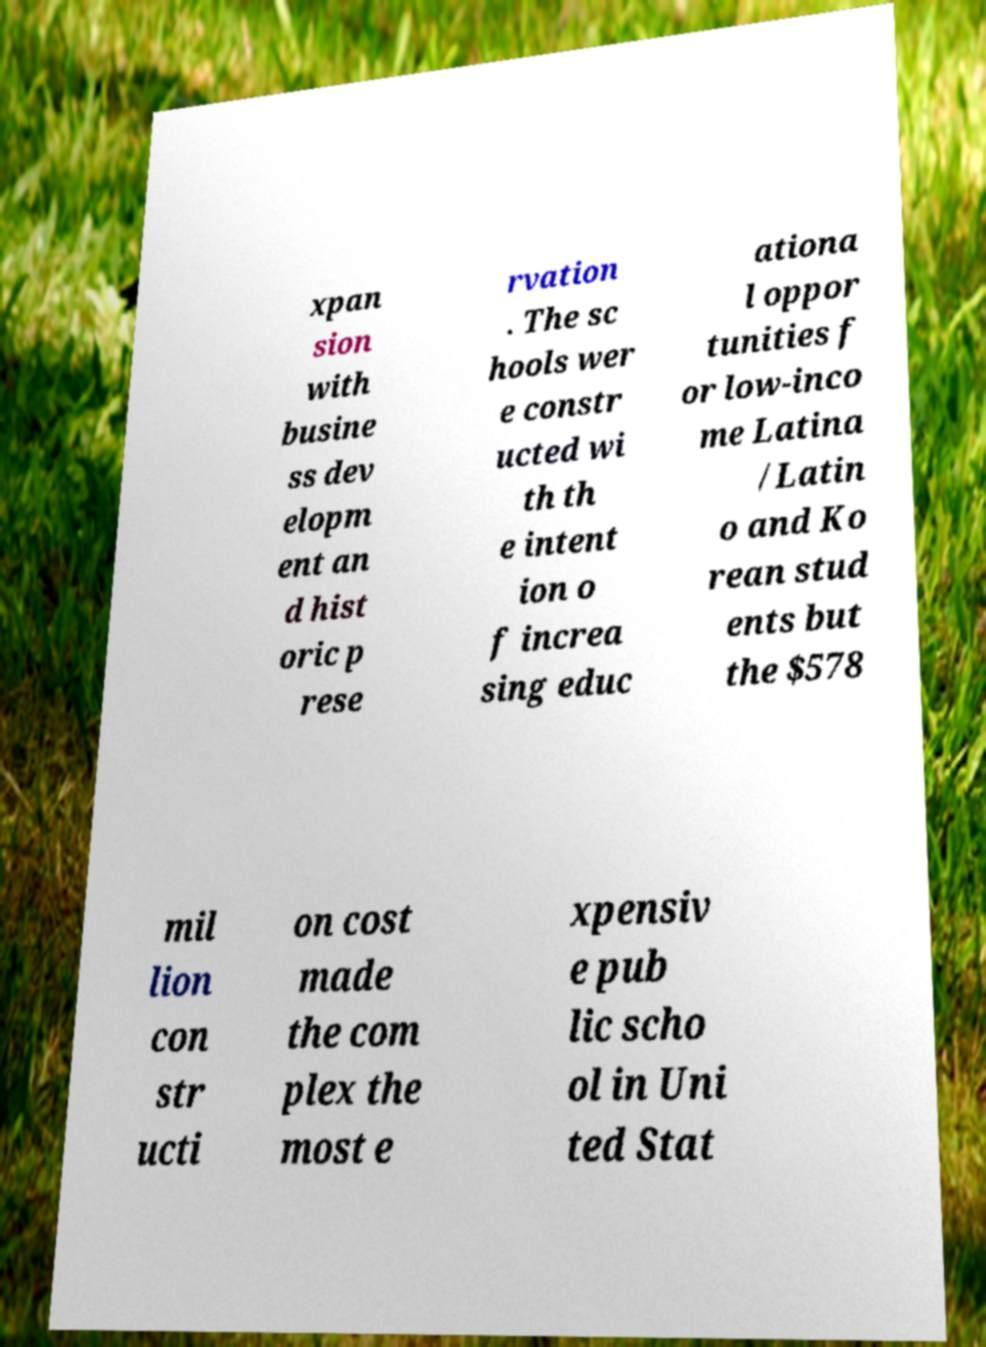What messages or text are displayed in this image? I need them in a readable, typed format. xpan sion with busine ss dev elopm ent an d hist oric p rese rvation . The sc hools wer e constr ucted wi th th e intent ion o f increa sing educ ationa l oppor tunities f or low-inco me Latina /Latin o and Ko rean stud ents but the $578 mil lion con str ucti on cost made the com plex the most e xpensiv e pub lic scho ol in Uni ted Stat 